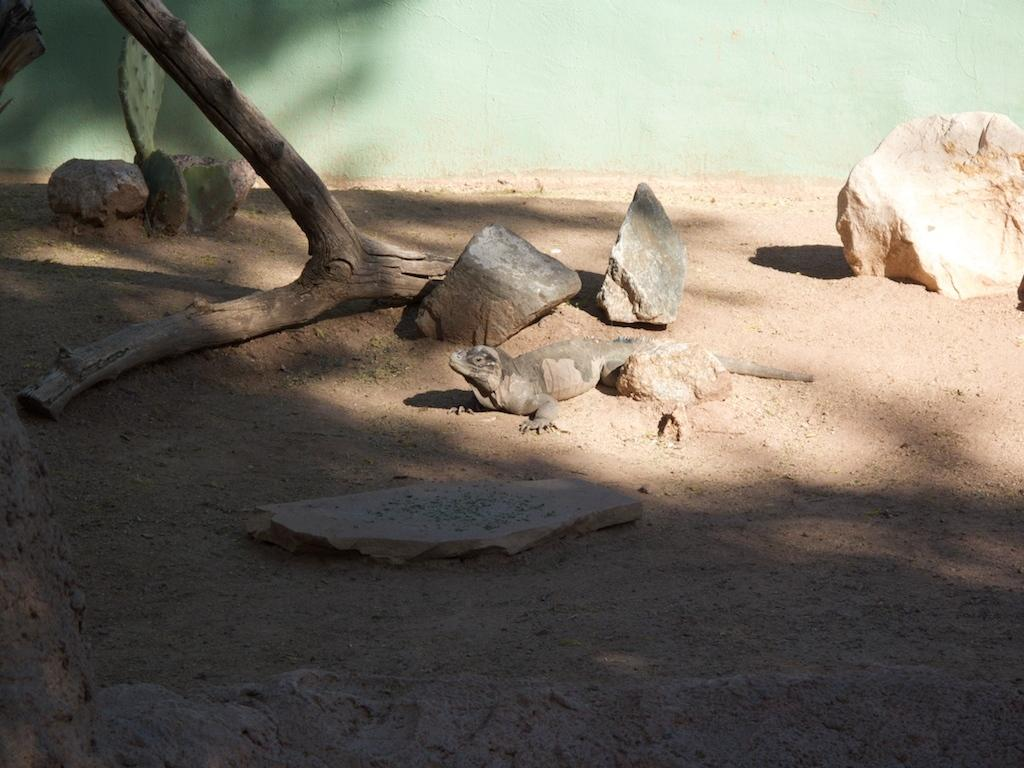What type of animal can be seen in the image? There is a reptile in the image. Where is the reptile located? The reptile is on the land. What other objects can be seen in the image? There are stones and a cactus plant visible in the image. What part of a tree is visible in the image? The bark of a tree is visible in the image. Can you see a fork being used by the reptile in the image? There is no fork present in the image, and the reptile is not using any utensils. 